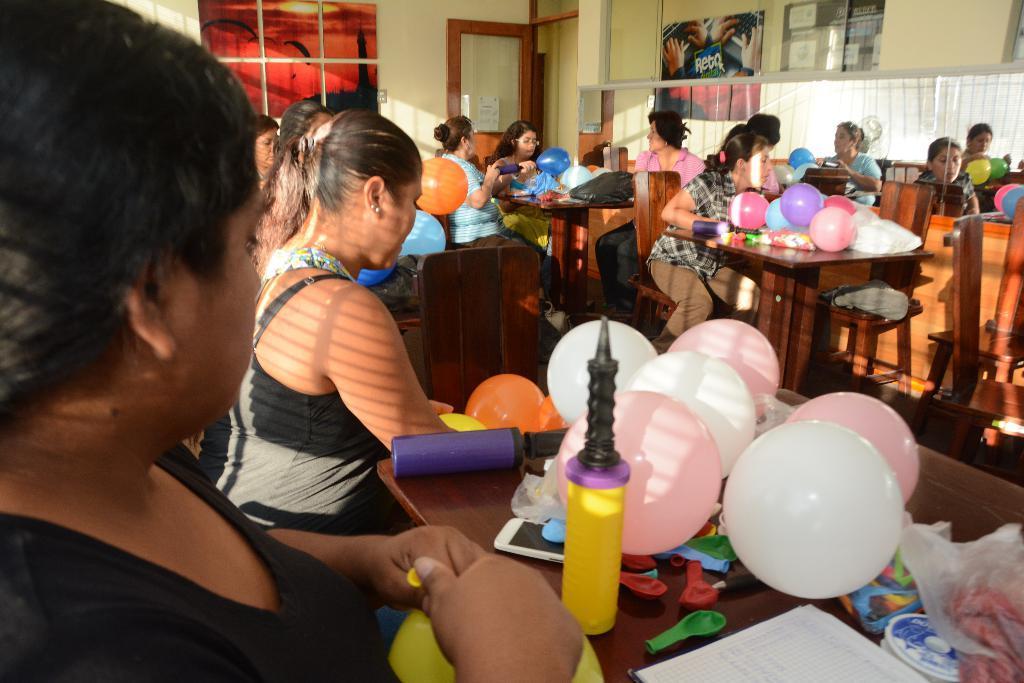How would you summarize this image in a sentence or two? In this picture there are group of people those who are sitting around the table and there are decorative pieces, balloons, and other art and crafts things which are placed on the table, there is a window at the left side of the image and there is a door at the center of the image. 